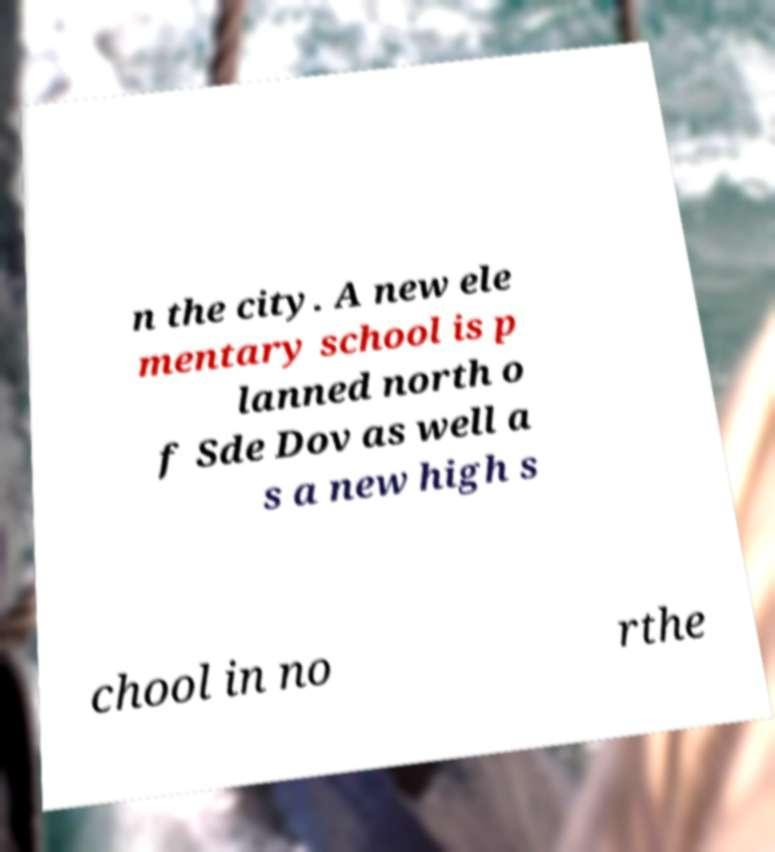What messages or text are displayed in this image? I need them in a readable, typed format. n the city. A new ele mentary school is p lanned north o f Sde Dov as well a s a new high s chool in no rthe 